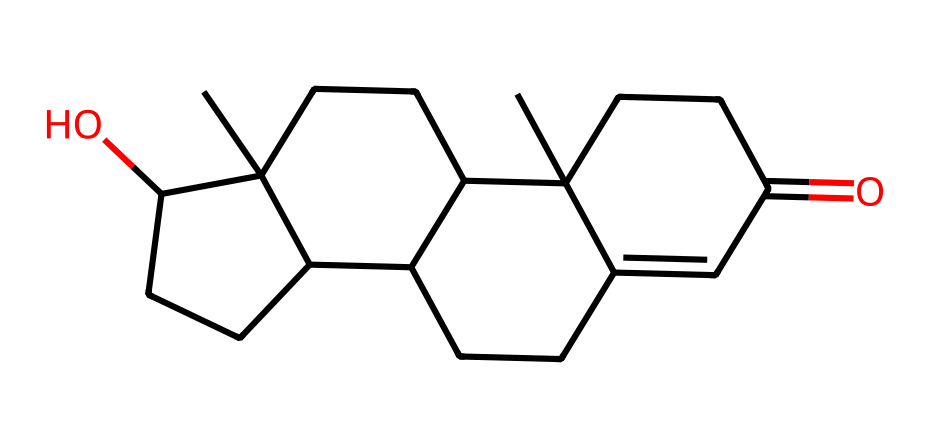What is the molecular formula of testosterone? To determine the molecular formula from the SMILES representation, we count the number of each type of atom present. The SMILES indicates there are 19 carbon atoms (C), 28 hydrogen atoms (H), and 2 oxygen atoms (O). Therefore, the molecular formula is C19H28O2.
Answer: C19H28O2 How many rings are present in the structure? The structure of testosterone contains four interconnected carbon rings, which can be visualized in the SMILES representation. Each digit in the SMILES denotes how rings are connected. Therefore, the answer is four rings.
Answer: four What type of functional group is present in testosterone? Analyzing the SMILES, there is a ketone functional group represented by the carbonyl (C=O) present at one of the carbon rings. This indicates that testosterone contains a ketone functional group.
Answer: ketone How many hydroxyl (-OH) groups are in the structure? The presence of an -OH group in the chemical is indicated by the "O" bonded to a carbon in the SMILES. Upon reviewing the SMILES string, there's one -OH group present in testosterone.
Answer: one Is this compound saturated or unsaturated? By examining the SMILES structure, we note that all carbon atoms are bonded to the maximum number of hydrogen atoms given the presence of rings and the functional groups, indicating it is saturated with hydrogen.
Answer: saturated What is the general structure type of testosterone? Testosterone can be categorized as a steroid due to its complex interconnected ring structure characteristic of steroid hormones. This is derived from its cyclopentanoperhydrophenanthrene backbone.
Answer: steroid 